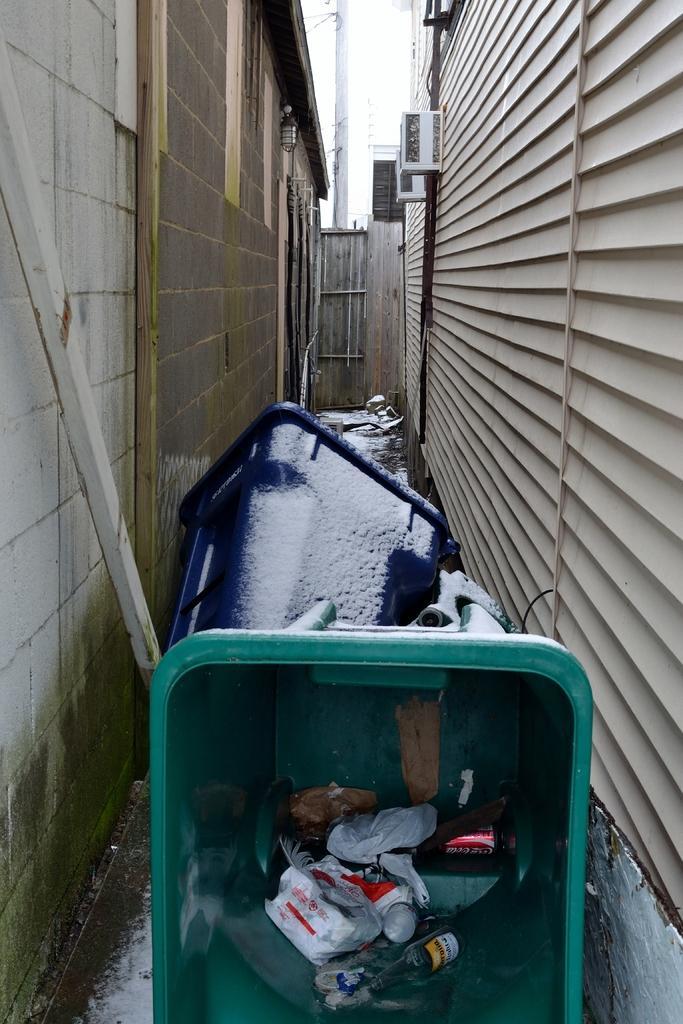Describe this image in one or two sentences. In this picture there are dustbins and there is garbage in the dustbin and there are buildings. At the back there is a pole and there are air conditioners on the wall. At the bottom there is water. At the top there is sky. 